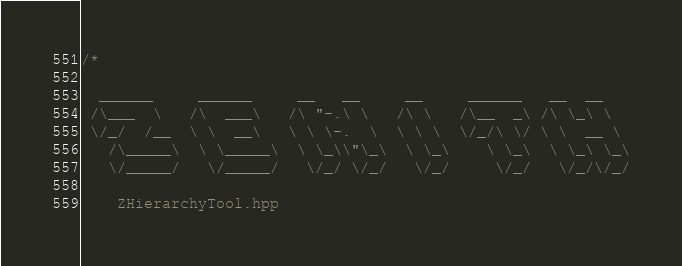<code> <loc_0><loc_0><loc_500><loc_500><_C++_>/*

  ______     ______     __   __     __     ______   __  __
 /\___  \   /\  ___\   /\ "-.\ \   /\ \   /\__  _\ /\ \_\ \
 \/_/  /__  \ \  __\   \ \ \-.  \  \ \ \  \/_/\ \/ \ \  __ \
   /\_____\  \ \_____\  \ \_\\"\_\  \ \_\    \ \_\  \ \_\ \_\
   \/_____/   \/_____/   \/_/ \/_/   \/_/     \/_/   \/_/\/_/

    ZHierarchyTool.hpp
</code> 